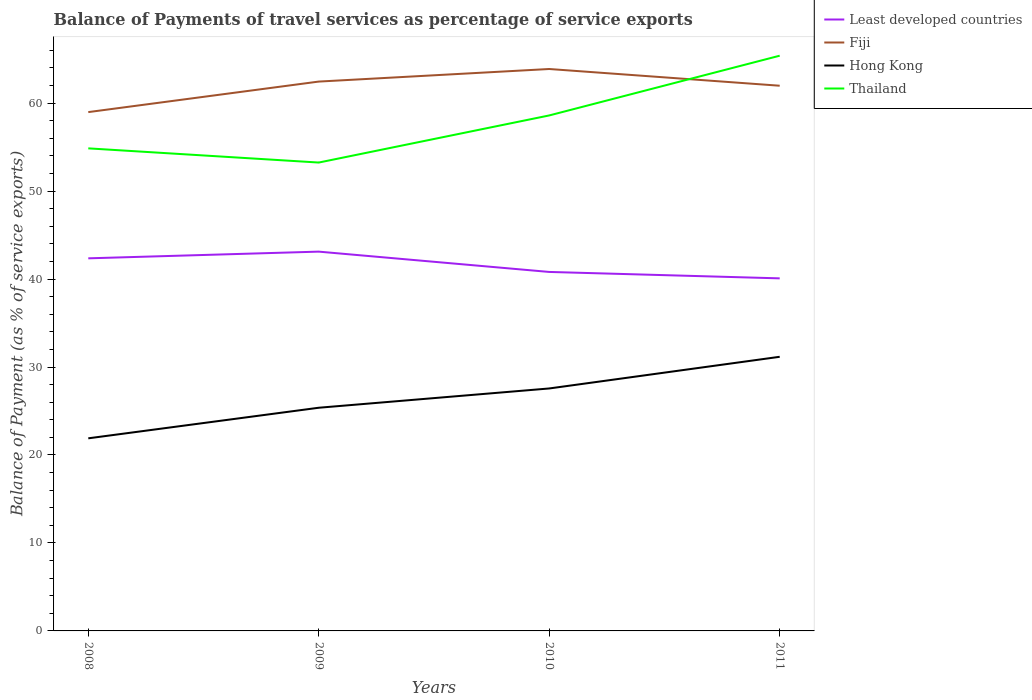How many different coloured lines are there?
Offer a terse response. 4. Does the line corresponding to Hong Kong intersect with the line corresponding to Thailand?
Your answer should be compact. No. Across all years, what is the maximum balance of payments of travel services in Thailand?
Provide a succinct answer. 53.25. What is the total balance of payments of travel services in Fiji in the graph?
Ensure brevity in your answer.  1.9. What is the difference between the highest and the second highest balance of payments of travel services in Thailand?
Provide a short and direct response. 12.15. What is the difference between the highest and the lowest balance of payments of travel services in Thailand?
Your answer should be compact. 2. How many years are there in the graph?
Give a very brief answer. 4. What is the difference between two consecutive major ticks on the Y-axis?
Provide a succinct answer. 10. Are the values on the major ticks of Y-axis written in scientific E-notation?
Offer a terse response. No. Where does the legend appear in the graph?
Keep it short and to the point. Top right. How many legend labels are there?
Your answer should be compact. 4. What is the title of the graph?
Give a very brief answer. Balance of Payments of travel services as percentage of service exports. What is the label or title of the X-axis?
Offer a very short reply. Years. What is the label or title of the Y-axis?
Provide a succinct answer. Balance of Payment (as % of service exports). What is the Balance of Payment (as % of service exports) in Least developed countries in 2008?
Offer a terse response. 42.36. What is the Balance of Payment (as % of service exports) in Fiji in 2008?
Keep it short and to the point. 58.98. What is the Balance of Payment (as % of service exports) of Hong Kong in 2008?
Offer a very short reply. 21.9. What is the Balance of Payment (as % of service exports) of Thailand in 2008?
Your answer should be compact. 54.86. What is the Balance of Payment (as % of service exports) in Least developed countries in 2009?
Provide a short and direct response. 43.12. What is the Balance of Payment (as % of service exports) in Fiji in 2009?
Ensure brevity in your answer.  62.45. What is the Balance of Payment (as % of service exports) in Hong Kong in 2009?
Your answer should be compact. 25.37. What is the Balance of Payment (as % of service exports) in Thailand in 2009?
Give a very brief answer. 53.25. What is the Balance of Payment (as % of service exports) of Least developed countries in 2010?
Give a very brief answer. 40.81. What is the Balance of Payment (as % of service exports) of Fiji in 2010?
Provide a short and direct response. 63.88. What is the Balance of Payment (as % of service exports) in Hong Kong in 2010?
Provide a short and direct response. 27.56. What is the Balance of Payment (as % of service exports) of Thailand in 2010?
Offer a very short reply. 58.6. What is the Balance of Payment (as % of service exports) in Least developed countries in 2011?
Keep it short and to the point. 40.08. What is the Balance of Payment (as % of service exports) of Fiji in 2011?
Keep it short and to the point. 61.98. What is the Balance of Payment (as % of service exports) of Hong Kong in 2011?
Provide a short and direct response. 31.16. What is the Balance of Payment (as % of service exports) of Thailand in 2011?
Make the answer very short. 65.39. Across all years, what is the maximum Balance of Payment (as % of service exports) of Least developed countries?
Give a very brief answer. 43.12. Across all years, what is the maximum Balance of Payment (as % of service exports) of Fiji?
Your response must be concise. 63.88. Across all years, what is the maximum Balance of Payment (as % of service exports) of Hong Kong?
Keep it short and to the point. 31.16. Across all years, what is the maximum Balance of Payment (as % of service exports) of Thailand?
Your answer should be very brief. 65.39. Across all years, what is the minimum Balance of Payment (as % of service exports) of Least developed countries?
Offer a terse response. 40.08. Across all years, what is the minimum Balance of Payment (as % of service exports) in Fiji?
Provide a succinct answer. 58.98. Across all years, what is the minimum Balance of Payment (as % of service exports) of Hong Kong?
Provide a short and direct response. 21.9. Across all years, what is the minimum Balance of Payment (as % of service exports) of Thailand?
Your response must be concise. 53.25. What is the total Balance of Payment (as % of service exports) in Least developed countries in the graph?
Offer a very short reply. 166.37. What is the total Balance of Payment (as % of service exports) in Fiji in the graph?
Give a very brief answer. 247.3. What is the total Balance of Payment (as % of service exports) of Hong Kong in the graph?
Offer a very short reply. 106. What is the total Balance of Payment (as % of service exports) of Thailand in the graph?
Provide a succinct answer. 232.1. What is the difference between the Balance of Payment (as % of service exports) in Least developed countries in 2008 and that in 2009?
Your response must be concise. -0.76. What is the difference between the Balance of Payment (as % of service exports) in Fiji in 2008 and that in 2009?
Your answer should be compact. -3.47. What is the difference between the Balance of Payment (as % of service exports) of Hong Kong in 2008 and that in 2009?
Keep it short and to the point. -3.48. What is the difference between the Balance of Payment (as % of service exports) in Thailand in 2008 and that in 2009?
Ensure brevity in your answer.  1.61. What is the difference between the Balance of Payment (as % of service exports) in Least developed countries in 2008 and that in 2010?
Keep it short and to the point. 1.55. What is the difference between the Balance of Payment (as % of service exports) of Fiji in 2008 and that in 2010?
Your answer should be very brief. -4.9. What is the difference between the Balance of Payment (as % of service exports) in Hong Kong in 2008 and that in 2010?
Your answer should be compact. -5.67. What is the difference between the Balance of Payment (as % of service exports) of Thailand in 2008 and that in 2010?
Ensure brevity in your answer.  -3.74. What is the difference between the Balance of Payment (as % of service exports) of Least developed countries in 2008 and that in 2011?
Ensure brevity in your answer.  2.28. What is the difference between the Balance of Payment (as % of service exports) of Fiji in 2008 and that in 2011?
Offer a very short reply. -3. What is the difference between the Balance of Payment (as % of service exports) of Hong Kong in 2008 and that in 2011?
Your response must be concise. -9.27. What is the difference between the Balance of Payment (as % of service exports) in Thailand in 2008 and that in 2011?
Offer a very short reply. -10.53. What is the difference between the Balance of Payment (as % of service exports) in Least developed countries in 2009 and that in 2010?
Make the answer very short. 2.31. What is the difference between the Balance of Payment (as % of service exports) of Fiji in 2009 and that in 2010?
Your answer should be compact. -1.43. What is the difference between the Balance of Payment (as % of service exports) of Hong Kong in 2009 and that in 2010?
Your response must be concise. -2.19. What is the difference between the Balance of Payment (as % of service exports) in Thailand in 2009 and that in 2010?
Ensure brevity in your answer.  -5.36. What is the difference between the Balance of Payment (as % of service exports) of Least developed countries in 2009 and that in 2011?
Your answer should be very brief. 3.04. What is the difference between the Balance of Payment (as % of service exports) in Fiji in 2009 and that in 2011?
Your answer should be very brief. 0.47. What is the difference between the Balance of Payment (as % of service exports) of Hong Kong in 2009 and that in 2011?
Give a very brief answer. -5.79. What is the difference between the Balance of Payment (as % of service exports) in Thailand in 2009 and that in 2011?
Your answer should be very brief. -12.15. What is the difference between the Balance of Payment (as % of service exports) in Least developed countries in 2010 and that in 2011?
Ensure brevity in your answer.  0.73. What is the difference between the Balance of Payment (as % of service exports) of Fiji in 2010 and that in 2011?
Offer a terse response. 1.9. What is the difference between the Balance of Payment (as % of service exports) of Hong Kong in 2010 and that in 2011?
Your response must be concise. -3.6. What is the difference between the Balance of Payment (as % of service exports) of Thailand in 2010 and that in 2011?
Offer a very short reply. -6.79. What is the difference between the Balance of Payment (as % of service exports) in Least developed countries in 2008 and the Balance of Payment (as % of service exports) in Fiji in 2009?
Your response must be concise. -20.09. What is the difference between the Balance of Payment (as % of service exports) of Least developed countries in 2008 and the Balance of Payment (as % of service exports) of Hong Kong in 2009?
Provide a succinct answer. 16.99. What is the difference between the Balance of Payment (as % of service exports) in Least developed countries in 2008 and the Balance of Payment (as % of service exports) in Thailand in 2009?
Your response must be concise. -10.89. What is the difference between the Balance of Payment (as % of service exports) of Fiji in 2008 and the Balance of Payment (as % of service exports) of Hong Kong in 2009?
Offer a terse response. 33.61. What is the difference between the Balance of Payment (as % of service exports) of Fiji in 2008 and the Balance of Payment (as % of service exports) of Thailand in 2009?
Offer a terse response. 5.74. What is the difference between the Balance of Payment (as % of service exports) in Hong Kong in 2008 and the Balance of Payment (as % of service exports) in Thailand in 2009?
Make the answer very short. -31.35. What is the difference between the Balance of Payment (as % of service exports) in Least developed countries in 2008 and the Balance of Payment (as % of service exports) in Fiji in 2010?
Keep it short and to the point. -21.52. What is the difference between the Balance of Payment (as % of service exports) in Least developed countries in 2008 and the Balance of Payment (as % of service exports) in Hong Kong in 2010?
Offer a very short reply. 14.79. What is the difference between the Balance of Payment (as % of service exports) of Least developed countries in 2008 and the Balance of Payment (as % of service exports) of Thailand in 2010?
Ensure brevity in your answer.  -16.24. What is the difference between the Balance of Payment (as % of service exports) in Fiji in 2008 and the Balance of Payment (as % of service exports) in Hong Kong in 2010?
Provide a short and direct response. 31.42. What is the difference between the Balance of Payment (as % of service exports) in Fiji in 2008 and the Balance of Payment (as % of service exports) in Thailand in 2010?
Make the answer very short. 0.38. What is the difference between the Balance of Payment (as % of service exports) of Hong Kong in 2008 and the Balance of Payment (as % of service exports) of Thailand in 2010?
Give a very brief answer. -36.71. What is the difference between the Balance of Payment (as % of service exports) of Least developed countries in 2008 and the Balance of Payment (as % of service exports) of Fiji in 2011?
Your answer should be very brief. -19.62. What is the difference between the Balance of Payment (as % of service exports) of Least developed countries in 2008 and the Balance of Payment (as % of service exports) of Hong Kong in 2011?
Provide a succinct answer. 11.19. What is the difference between the Balance of Payment (as % of service exports) in Least developed countries in 2008 and the Balance of Payment (as % of service exports) in Thailand in 2011?
Provide a succinct answer. -23.03. What is the difference between the Balance of Payment (as % of service exports) of Fiji in 2008 and the Balance of Payment (as % of service exports) of Hong Kong in 2011?
Offer a very short reply. 27.82. What is the difference between the Balance of Payment (as % of service exports) in Fiji in 2008 and the Balance of Payment (as % of service exports) in Thailand in 2011?
Keep it short and to the point. -6.41. What is the difference between the Balance of Payment (as % of service exports) in Hong Kong in 2008 and the Balance of Payment (as % of service exports) in Thailand in 2011?
Your answer should be very brief. -43.5. What is the difference between the Balance of Payment (as % of service exports) of Least developed countries in 2009 and the Balance of Payment (as % of service exports) of Fiji in 2010?
Make the answer very short. -20.76. What is the difference between the Balance of Payment (as % of service exports) of Least developed countries in 2009 and the Balance of Payment (as % of service exports) of Hong Kong in 2010?
Your answer should be compact. 15.56. What is the difference between the Balance of Payment (as % of service exports) of Least developed countries in 2009 and the Balance of Payment (as % of service exports) of Thailand in 2010?
Ensure brevity in your answer.  -15.48. What is the difference between the Balance of Payment (as % of service exports) in Fiji in 2009 and the Balance of Payment (as % of service exports) in Hong Kong in 2010?
Provide a succinct answer. 34.89. What is the difference between the Balance of Payment (as % of service exports) of Fiji in 2009 and the Balance of Payment (as % of service exports) of Thailand in 2010?
Your response must be concise. 3.85. What is the difference between the Balance of Payment (as % of service exports) of Hong Kong in 2009 and the Balance of Payment (as % of service exports) of Thailand in 2010?
Offer a terse response. -33.23. What is the difference between the Balance of Payment (as % of service exports) of Least developed countries in 2009 and the Balance of Payment (as % of service exports) of Fiji in 2011?
Your answer should be very brief. -18.86. What is the difference between the Balance of Payment (as % of service exports) in Least developed countries in 2009 and the Balance of Payment (as % of service exports) in Hong Kong in 2011?
Offer a very short reply. 11.95. What is the difference between the Balance of Payment (as % of service exports) of Least developed countries in 2009 and the Balance of Payment (as % of service exports) of Thailand in 2011?
Your answer should be very brief. -22.27. What is the difference between the Balance of Payment (as % of service exports) in Fiji in 2009 and the Balance of Payment (as % of service exports) in Hong Kong in 2011?
Provide a short and direct response. 31.29. What is the difference between the Balance of Payment (as % of service exports) of Fiji in 2009 and the Balance of Payment (as % of service exports) of Thailand in 2011?
Your response must be concise. -2.94. What is the difference between the Balance of Payment (as % of service exports) of Hong Kong in 2009 and the Balance of Payment (as % of service exports) of Thailand in 2011?
Your answer should be very brief. -40.02. What is the difference between the Balance of Payment (as % of service exports) in Least developed countries in 2010 and the Balance of Payment (as % of service exports) in Fiji in 2011?
Make the answer very short. -21.17. What is the difference between the Balance of Payment (as % of service exports) in Least developed countries in 2010 and the Balance of Payment (as % of service exports) in Hong Kong in 2011?
Your response must be concise. 9.65. What is the difference between the Balance of Payment (as % of service exports) of Least developed countries in 2010 and the Balance of Payment (as % of service exports) of Thailand in 2011?
Provide a succinct answer. -24.58. What is the difference between the Balance of Payment (as % of service exports) of Fiji in 2010 and the Balance of Payment (as % of service exports) of Hong Kong in 2011?
Your answer should be very brief. 32.72. What is the difference between the Balance of Payment (as % of service exports) in Fiji in 2010 and the Balance of Payment (as % of service exports) in Thailand in 2011?
Your answer should be very brief. -1.51. What is the difference between the Balance of Payment (as % of service exports) in Hong Kong in 2010 and the Balance of Payment (as % of service exports) in Thailand in 2011?
Give a very brief answer. -37.83. What is the average Balance of Payment (as % of service exports) in Least developed countries per year?
Your answer should be very brief. 41.59. What is the average Balance of Payment (as % of service exports) in Fiji per year?
Your answer should be compact. 61.82. What is the average Balance of Payment (as % of service exports) of Hong Kong per year?
Make the answer very short. 26.5. What is the average Balance of Payment (as % of service exports) in Thailand per year?
Offer a very short reply. 58.03. In the year 2008, what is the difference between the Balance of Payment (as % of service exports) of Least developed countries and Balance of Payment (as % of service exports) of Fiji?
Offer a terse response. -16.62. In the year 2008, what is the difference between the Balance of Payment (as % of service exports) of Least developed countries and Balance of Payment (as % of service exports) of Hong Kong?
Give a very brief answer. 20.46. In the year 2008, what is the difference between the Balance of Payment (as % of service exports) in Least developed countries and Balance of Payment (as % of service exports) in Thailand?
Ensure brevity in your answer.  -12.5. In the year 2008, what is the difference between the Balance of Payment (as % of service exports) in Fiji and Balance of Payment (as % of service exports) in Hong Kong?
Your response must be concise. 37.09. In the year 2008, what is the difference between the Balance of Payment (as % of service exports) of Fiji and Balance of Payment (as % of service exports) of Thailand?
Provide a succinct answer. 4.12. In the year 2008, what is the difference between the Balance of Payment (as % of service exports) in Hong Kong and Balance of Payment (as % of service exports) in Thailand?
Your response must be concise. -32.96. In the year 2009, what is the difference between the Balance of Payment (as % of service exports) of Least developed countries and Balance of Payment (as % of service exports) of Fiji?
Keep it short and to the point. -19.33. In the year 2009, what is the difference between the Balance of Payment (as % of service exports) of Least developed countries and Balance of Payment (as % of service exports) of Hong Kong?
Keep it short and to the point. 17.75. In the year 2009, what is the difference between the Balance of Payment (as % of service exports) in Least developed countries and Balance of Payment (as % of service exports) in Thailand?
Keep it short and to the point. -10.13. In the year 2009, what is the difference between the Balance of Payment (as % of service exports) in Fiji and Balance of Payment (as % of service exports) in Hong Kong?
Your answer should be compact. 37.08. In the year 2009, what is the difference between the Balance of Payment (as % of service exports) of Fiji and Balance of Payment (as % of service exports) of Thailand?
Offer a very short reply. 9.21. In the year 2009, what is the difference between the Balance of Payment (as % of service exports) of Hong Kong and Balance of Payment (as % of service exports) of Thailand?
Your answer should be compact. -27.87. In the year 2010, what is the difference between the Balance of Payment (as % of service exports) in Least developed countries and Balance of Payment (as % of service exports) in Fiji?
Make the answer very short. -23.07. In the year 2010, what is the difference between the Balance of Payment (as % of service exports) in Least developed countries and Balance of Payment (as % of service exports) in Hong Kong?
Your response must be concise. 13.25. In the year 2010, what is the difference between the Balance of Payment (as % of service exports) of Least developed countries and Balance of Payment (as % of service exports) of Thailand?
Offer a very short reply. -17.79. In the year 2010, what is the difference between the Balance of Payment (as % of service exports) of Fiji and Balance of Payment (as % of service exports) of Hong Kong?
Ensure brevity in your answer.  36.32. In the year 2010, what is the difference between the Balance of Payment (as % of service exports) in Fiji and Balance of Payment (as % of service exports) in Thailand?
Your answer should be compact. 5.28. In the year 2010, what is the difference between the Balance of Payment (as % of service exports) in Hong Kong and Balance of Payment (as % of service exports) in Thailand?
Make the answer very short. -31.04. In the year 2011, what is the difference between the Balance of Payment (as % of service exports) in Least developed countries and Balance of Payment (as % of service exports) in Fiji?
Make the answer very short. -21.9. In the year 2011, what is the difference between the Balance of Payment (as % of service exports) in Least developed countries and Balance of Payment (as % of service exports) in Hong Kong?
Offer a terse response. 8.92. In the year 2011, what is the difference between the Balance of Payment (as % of service exports) in Least developed countries and Balance of Payment (as % of service exports) in Thailand?
Give a very brief answer. -25.31. In the year 2011, what is the difference between the Balance of Payment (as % of service exports) of Fiji and Balance of Payment (as % of service exports) of Hong Kong?
Keep it short and to the point. 30.82. In the year 2011, what is the difference between the Balance of Payment (as % of service exports) of Fiji and Balance of Payment (as % of service exports) of Thailand?
Provide a succinct answer. -3.41. In the year 2011, what is the difference between the Balance of Payment (as % of service exports) of Hong Kong and Balance of Payment (as % of service exports) of Thailand?
Ensure brevity in your answer.  -34.23. What is the ratio of the Balance of Payment (as % of service exports) of Least developed countries in 2008 to that in 2009?
Give a very brief answer. 0.98. What is the ratio of the Balance of Payment (as % of service exports) in Hong Kong in 2008 to that in 2009?
Offer a very short reply. 0.86. What is the ratio of the Balance of Payment (as % of service exports) in Thailand in 2008 to that in 2009?
Make the answer very short. 1.03. What is the ratio of the Balance of Payment (as % of service exports) in Least developed countries in 2008 to that in 2010?
Ensure brevity in your answer.  1.04. What is the ratio of the Balance of Payment (as % of service exports) of Fiji in 2008 to that in 2010?
Your response must be concise. 0.92. What is the ratio of the Balance of Payment (as % of service exports) of Hong Kong in 2008 to that in 2010?
Ensure brevity in your answer.  0.79. What is the ratio of the Balance of Payment (as % of service exports) in Thailand in 2008 to that in 2010?
Make the answer very short. 0.94. What is the ratio of the Balance of Payment (as % of service exports) in Least developed countries in 2008 to that in 2011?
Provide a short and direct response. 1.06. What is the ratio of the Balance of Payment (as % of service exports) of Fiji in 2008 to that in 2011?
Ensure brevity in your answer.  0.95. What is the ratio of the Balance of Payment (as % of service exports) in Hong Kong in 2008 to that in 2011?
Give a very brief answer. 0.7. What is the ratio of the Balance of Payment (as % of service exports) of Thailand in 2008 to that in 2011?
Make the answer very short. 0.84. What is the ratio of the Balance of Payment (as % of service exports) of Least developed countries in 2009 to that in 2010?
Ensure brevity in your answer.  1.06. What is the ratio of the Balance of Payment (as % of service exports) of Fiji in 2009 to that in 2010?
Ensure brevity in your answer.  0.98. What is the ratio of the Balance of Payment (as % of service exports) in Hong Kong in 2009 to that in 2010?
Your answer should be very brief. 0.92. What is the ratio of the Balance of Payment (as % of service exports) in Thailand in 2009 to that in 2010?
Give a very brief answer. 0.91. What is the ratio of the Balance of Payment (as % of service exports) of Least developed countries in 2009 to that in 2011?
Offer a terse response. 1.08. What is the ratio of the Balance of Payment (as % of service exports) of Fiji in 2009 to that in 2011?
Make the answer very short. 1.01. What is the ratio of the Balance of Payment (as % of service exports) in Hong Kong in 2009 to that in 2011?
Offer a terse response. 0.81. What is the ratio of the Balance of Payment (as % of service exports) of Thailand in 2009 to that in 2011?
Offer a very short reply. 0.81. What is the ratio of the Balance of Payment (as % of service exports) in Least developed countries in 2010 to that in 2011?
Ensure brevity in your answer.  1.02. What is the ratio of the Balance of Payment (as % of service exports) in Fiji in 2010 to that in 2011?
Provide a succinct answer. 1.03. What is the ratio of the Balance of Payment (as % of service exports) in Hong Kong in 2010 to that in 2011?
Provide a succinct answer. 0.88. What is the ratio of the Balance of Payment (as % of service exports) of Thailand in 2010 to that in 2011?
Give a very brief answer. 0.9. What is the difference between the highest and the second highest Balance of Payment (as % of service exports) in Least developed countries?
Your answer should be compact. 0.76. What is the difference between the highest and the second highest Balance of Payment (as % of service exports) of Fiji?
Make the answer very short. 1.43. What is the difference between the highest and the second highest Balance of Payment (as % of service exports) in Hong Kong?
Your answer should be very brief. 3.6. What is the difference between the highest and the second highest Balance of Payment (as % of service exports) of Thailand?
Ensure brevity in your answer.  6.79. What is the difference between the highest and the lowest Balance of Payment (as % of service exports) in Least developed countries?
Ensure brevity in your answer.  3.04. What is the difference between the highest and the lowest Balance of Payment (as % of service exports) of Fiji?
Provide a succinct answer. 4.9. What is the difference between the highest and the lowest Balance of Payment (as % of service exports) of Hong Kong?
Ensure brevity in your answer.  9.27. What is the difference between the highest and the lowest Balance of Payment (as % of service exports) in Thailand?
Offer a terse response. 12.15. 